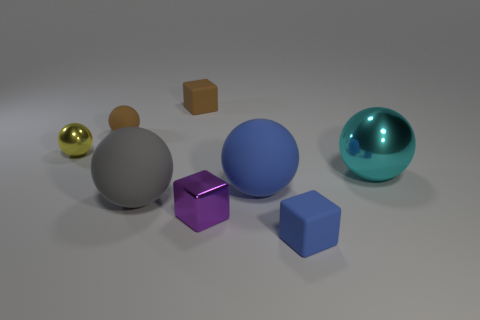Subtract all yellow balls. How many balls are left? 4 Subtract all yellow metallic balls. How many balls are left? 4 Subtract 1 balls. How many balls are left? 4 Subtract all red balls. Subtract all gray blocks. How many balls are left? 5 Add 1 big yellow metallic things. How many objects exist? 9 Subtract all spheres. How many objects are left? 3 Add 7 shiny things. How many shiny things exist? 10 Subtract 0 yellow blocks. How many objects are left? 8 Subtract all tiny things. Subtract all matte blocks. How many objects are left? 1 Add 7 small blocks. How many small blocks are left? 10 